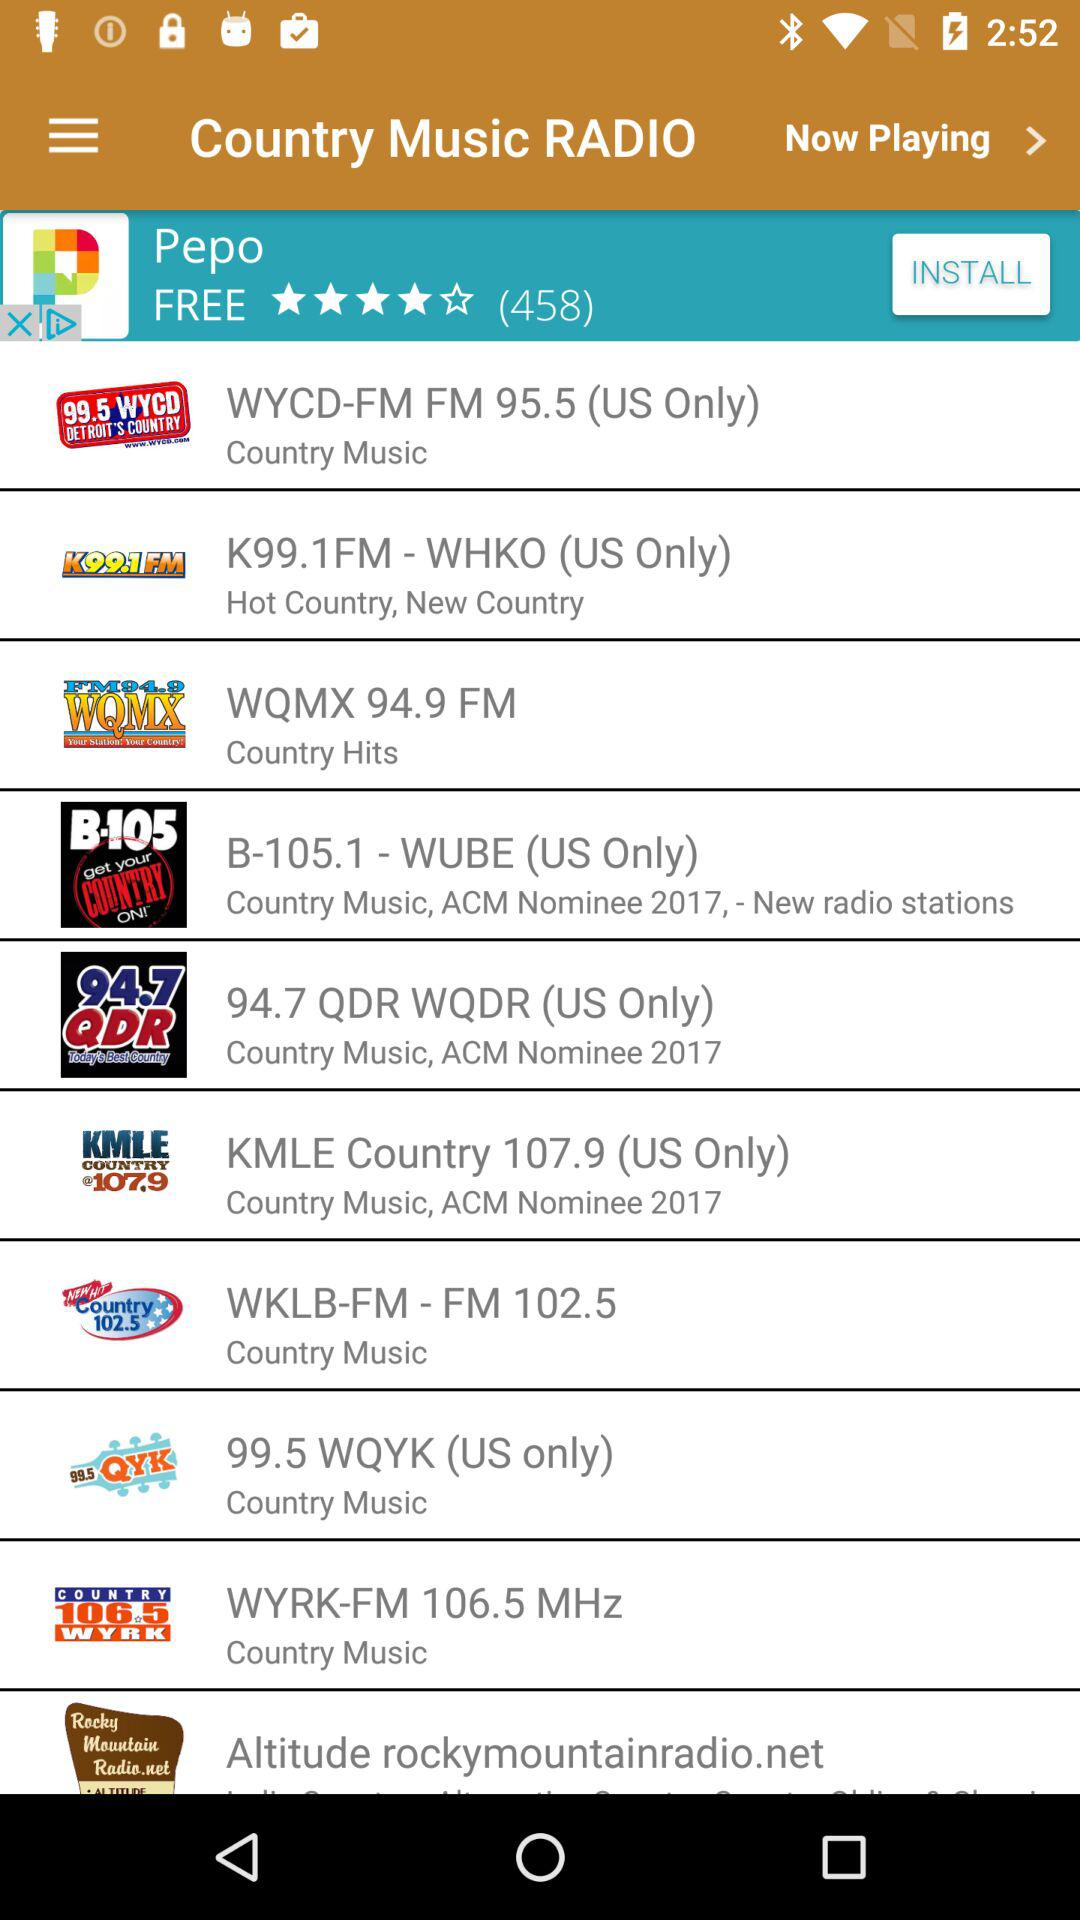What radio station has country hits? The radio station is "WQMX 94.9 FM". 